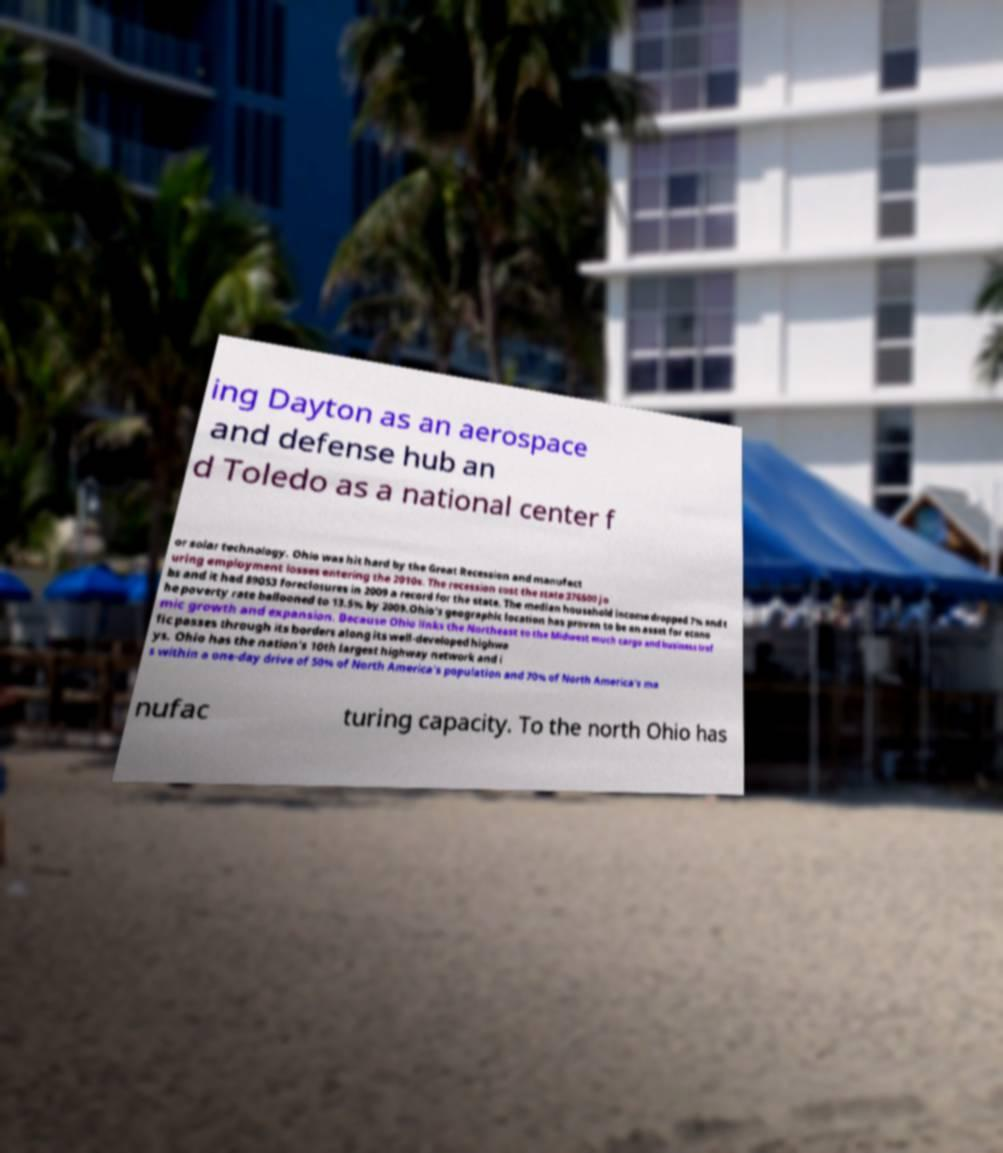There's text embedded in this image that I need extracted. Can you transcribe it verbatim? ing Dayton as an aerospace and defense hub an d Toledo as a national center f or solar technology. Ohio was hit hard by the Great Recession and manufact uring employment losses entering the 2010s. The recession cost the state 376500 jo bs and it had 89053 foreclosures in 2009 a record for the state. The median household income dropped 7% and t he poverty rate ballooned to 13.5% by 2009.Ohio's geographic location has proven to be an asset for econo mic growth and expansion. Because Ohio links the Northeast to the Midwest much cargo and business traf fic passes through its borders along its well-developed highwa ys. Ohio has the nation's 10th largest highway network and i s within a one-day drive of 50% of North America's population and 70% of North America's ma nufac turing capacity. To the north Ohio has 